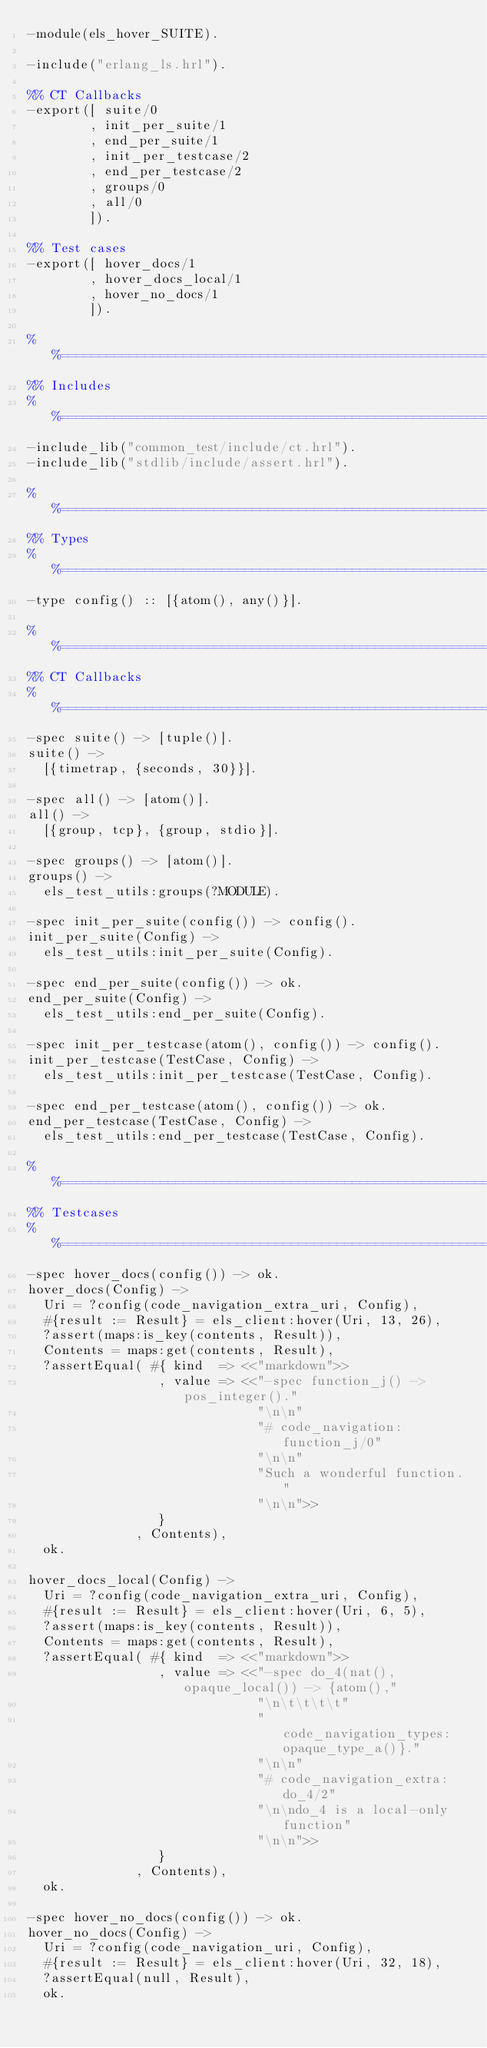Convert code to text. <code><loc_0><loc_0><loc_500><loc_500><_Erlang_>-module(els_hover_SUITE).

-include("erlang_ls.hrl").

%% CT Callbacks
-export([ suite/0
        , init_per_suite/1
        , end_per_suite/1
        , init_per_testcase/2
        , end_per_testcase/2
        , groups/0
        , all/0
        ]).

%% Test cases
-export([ hover_docs/1
        , hover_docs_local/1
        , hover_no_docs/1
        ]).

%%==============================================================================
%% Includes
%%==============================================================================
-include_lib("common_test/include/ct.hrl").
-include_lib("stdlib/include/assert.hrl").

%%==============================================================================
%% Types
%%==============================================================================
-type config() :: [{atom(), any()}].

%%==============================================================================
%% CT Callbacks
%%==============================================================================
-spec suite() -> [tuple()].
suite() ->
  [{timetrap, {seconds, 30}}].

-spec all() -> [atom()].
all() ->
  [{group, tcp}, {group, stdio}].

-spec groups() -> [atom()].
groups() ->
  els_test_utils:groups(?MODULE).

-spec init_per_suite(config()) -> config().
init_per_suite(Config) ->
  els_test_utils:init_per_suite(Config).

-spec end_per_suite(config()) -> ok.
end_per_suite(Config) ->
  els_test_utils:end_per_suite(Config).

-spec init_per_testcase(atom(), config()) -> config().
init_per_testcase(TestCase, Config) ->
  els_test_utils:init_per_testcase(TestCase, Config).

-spec end_per_testcase(atom(), config()) -> ok.
end_per_testcase(TestCase, Config) ->
  els_test_utils:end_per_testcase(TestCase, Config).

%%==============================================================================
%% Testcases
%%==============================================================================
-spec hover_docs(config()) -> ok.
hover_docs(Config) ->
  Uri = ?config(code_navigation_extra_uri, Config),
  #{result := Result} = els_client:hover(Uri, 13, 26),
  ?assert(maps:is_key(contents, Result)),
  Contents = maps:get(contents, Result),
  ?assertEqual( #{ kind  => <<"markdown">>
                 , value => <<"-spec function_j() -> pos_integer()."
                              "\n\n"
                              "# code_navigation:function_j/0"
                              "\n\n"
                              "Such a wonderful function."
                              "\n\n">>
                 }
              , Contents),
  ok.

hover_docs_local(Config) ->
  Uri = ?config(code_navigation_extra_uri, Config),
  #{result := Result} = els_client:hover(Uri, 6, 5),
  ?assert(maps:is_key(contents, Result)),
  Contents = maps:get(contents, Result),
  ?assertEqual( #{ kind  => <<"markdown">>
                 , value => <<"-spec do_4(nat(), opaque_local()) -> {atom(),"
                              "\n\t\t\t\t"
                              "      code_navigation_types:opaque_type_a()}."
                              "\n\n"
                              "# code_navigation_extra:do_4/2"
                              "\n\ndo_4 is a local-only function"
                              "\n\n">>
                 }
              , Contents),
  ok.

-spec hover_no_docs(config()) -> ok.
hover_no_docs(Config) ->
  Uri = ?config(code_navigation_uri, Config),
  #{result := Result} = els_client:hover(Uri, 32, 18),
  ?assertEqual(null, Result),
  ok.
</code> 